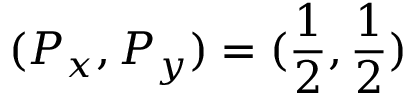<formula> <loc_0><loc_0><loc_500><loc_500>( P _ { x } , P _ { y } ) = ( \frac { 1 } { 2 } , \frac { 1 } { 2 } )</formula> 